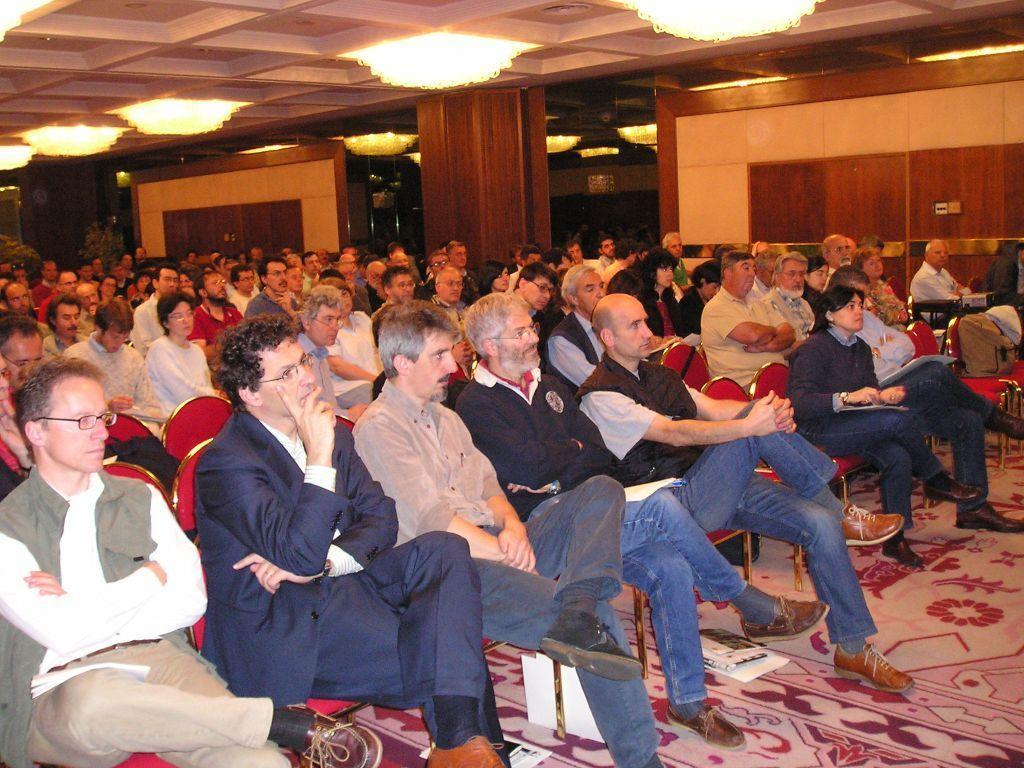In one or two sentences, can you explain what this image depicts? In this picture there are many people seated in chairs. At the top there are chandeliers to the ceiling. In the center of the background there are plants, wall and pillar. In the foreground there are books. On the right there is a bag on the chair. 